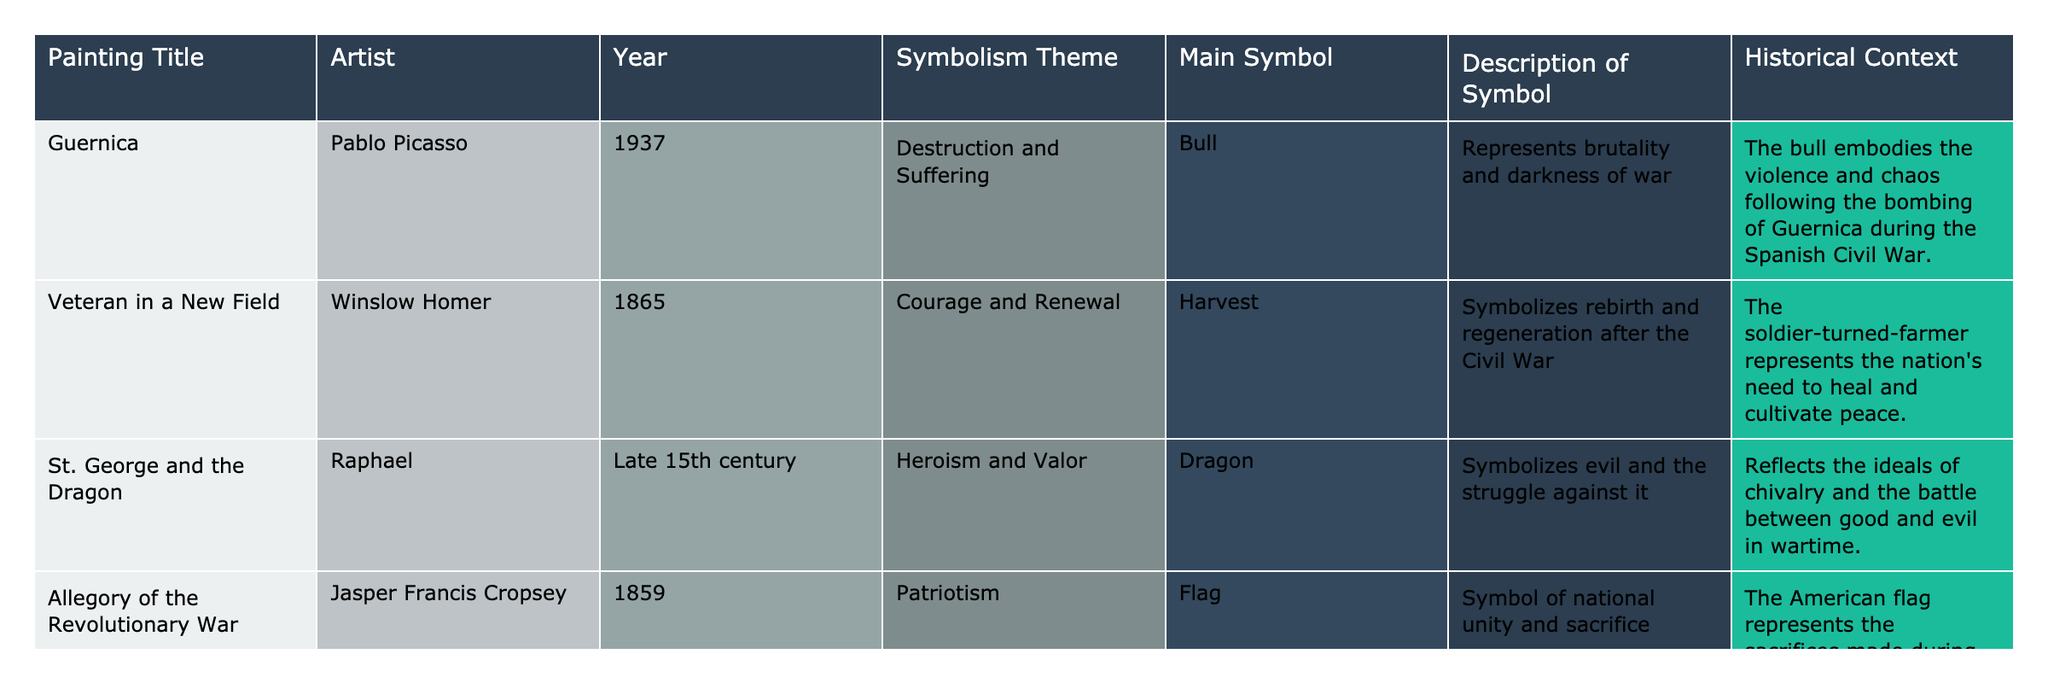What is the main symbol used in "Guernica"? By looking at the table, I can see under the "Main Symbol" column for "Guernica" that the main symbol is a "Bull."
Answer: Bull Which painting was created first, "St. George and the Dragon" or "Veteran in a New Field"? The year for "St. George and the Dragon" is listed as the late 15th century, while "Veteran in a New Field" is from 1865. Since the late 15th century is earlier than 1865, "St. George and the Dragon" was created first.
Answer: St. George and the Dragon What symbolism theme does "Allegory of the Revolutionary War" represent? Referring to the table, the symbolism theme for "Allegory of the Revolutionary War" is "Patriotism."
Answer: Patriotism How many paintings have a symbolism of destruction or suffering? Looking at the "Symbolism Theme" column, only "Guernica" falls under "Destruction and Suffering." Therefore, there is only one painting with this theme.
Answer: 1 Is the main symbol for "Veteran in a New Field" a flag? The main symbol for "Veteran in a New Field" is "Harvest," which can be checked in the table. Therefore, this statement is false.
Answer: No Which painting uses a dragon as the main symbol and what does it symbolize? Referring to the table, "St. George and the Dragon" uses a "Dragon" as the main symbol, which symbolizes evil and the struggle against it.
Answer: St. George and the Dragon; evil and struggle How many unique symbolism themes are represented in the table? The themes listed in the table are "Destruction and Suffering," "Courage and Renewal," "Heroism and Valor," and "Patriotism," which makes a total of four unique themes.
Answer: 4 Which painting has a historical context related to the Civil War? When examining the historical contexts, both "Veteran in a New Field" and "Guernica" are tied to a civil war context; however, "Veteran in a New Field" explicitly references the Civil War.
Answer: Veteran in a New Field What is the main symbol for "Allegory of the Revolutionary War"? The main symbol for "Allegory of the Revolutionary War," as stated in the table, is the "Flag."
Answer: Flag Which two paintings depict themes of hope or renewal? By analyzing the symbolism themes, "Veteran in a New Field" represents "Courage and Renewal," which reflects hope. The other paintings focus on destruction, heroism, or patriotism, making only "Veteran in a New Field" relevant here.
Answer: Veteran in a New Field What decade is "Guernica" from? The year listed for "Guernica" is 1937, which falls within the 1930s decade.
Answer: 1930s 